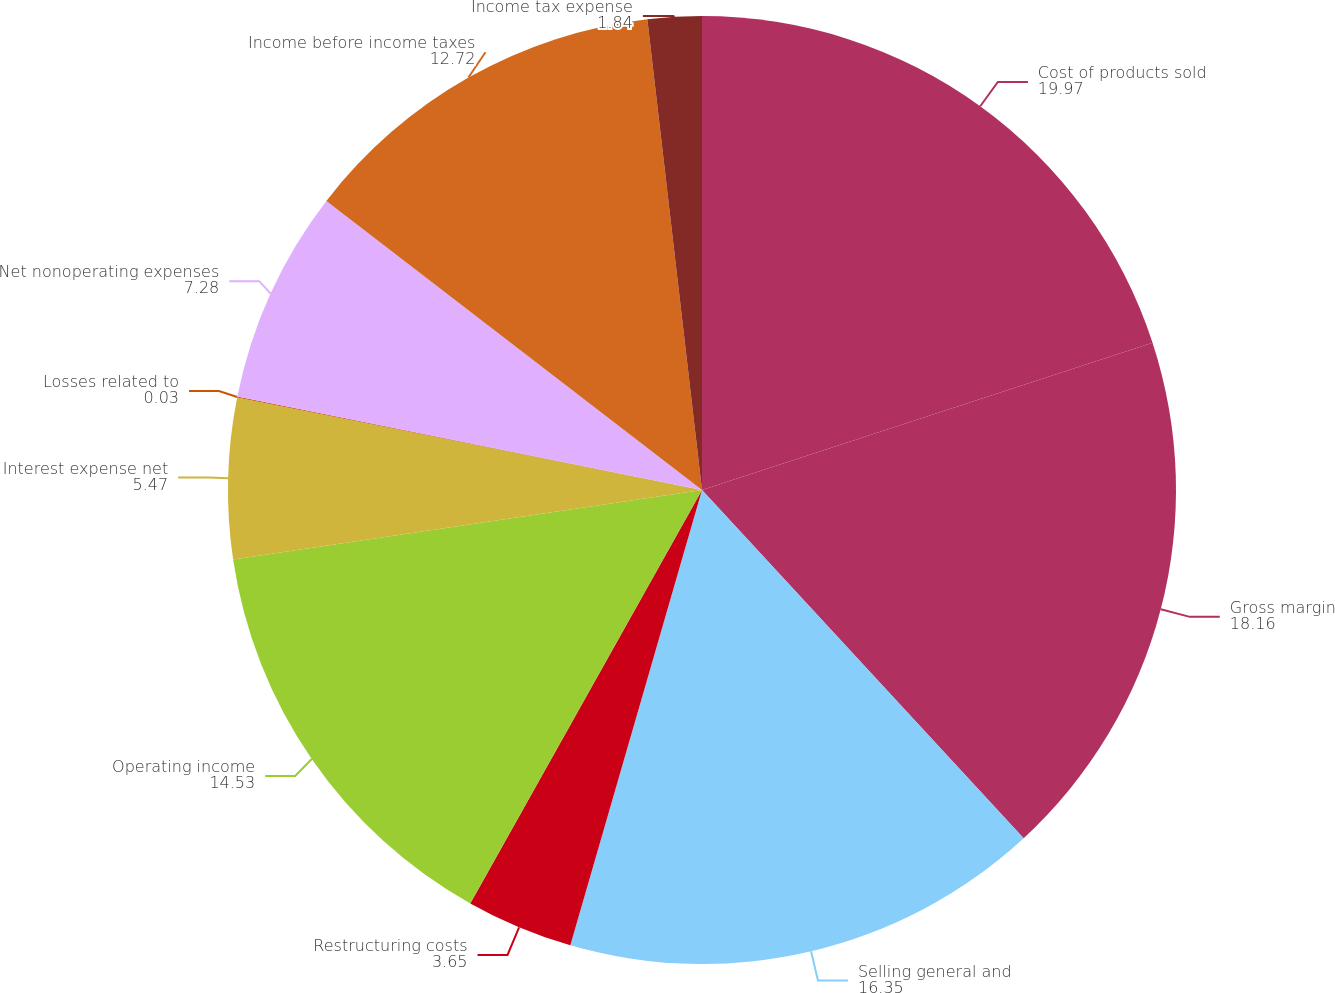<chart> <loc_0><loc_0><loc_500><loc_500><pie_chart><fcel>Cost of products sold<fcel>Gross margin<fcel>Selling general and<fcel>Restructuring costs<fcel>Operating income<fcel>Interest expense net<fcel>Losses related to<fcel>Net nonoperating expenses<fcel>Income before income taxes<fcel>Income tax expense<nl><fcel>19.97%<fcel>18.16%<fcel>16.35%<fcel>3.65%<fcel>14.53%<fcel>5.47%<fcel>0.03%<fcel>7.28%<fcel>12.72%<fcel>1.84%<nl></chart> 